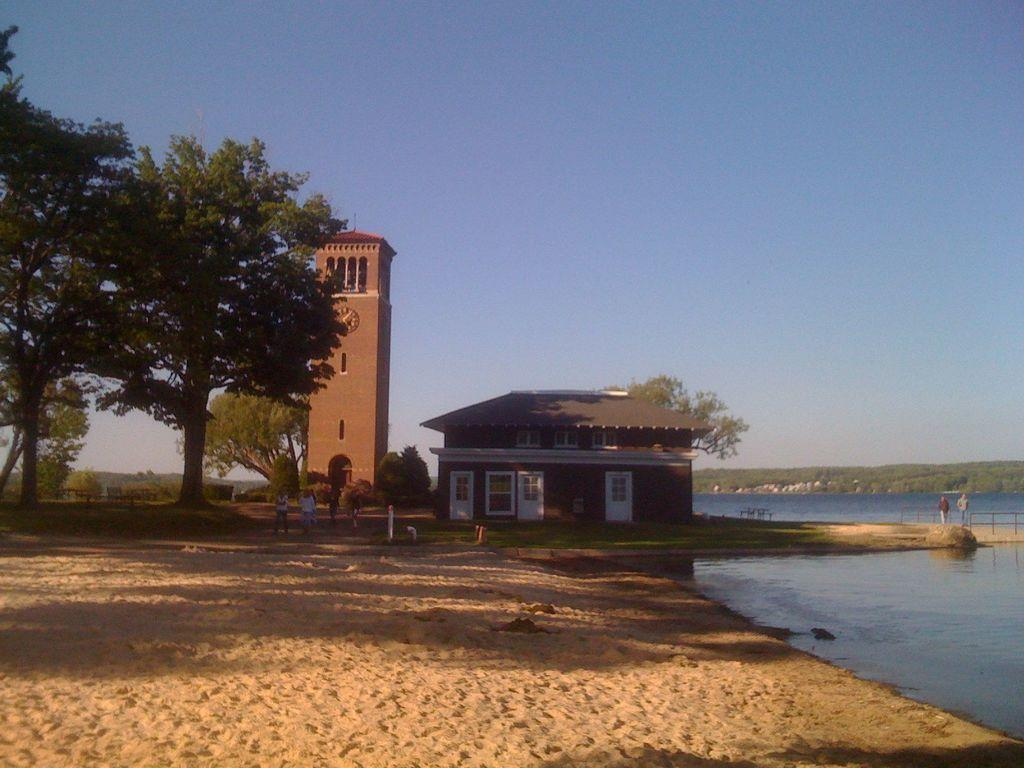What type of structure can be seen in the image? There is a house and a tower in the image. What time-related object is present in the image? There is a clock in the image. What type of vegetation is visible in the image? There are trees and grass in the image. What is the background of the image? There is sky visible in the image. Are there any people in the image? Yes, there are people in the image. What type of architectural feature can be seen in the image? There are railings in the image. What natural element is visible in the image? There is water visible in the image. What unspecified objects can be seen in the image? There are unspecified objects in the image. How many bells are hanging from the shelf in the image? There is no shelf present in the image, and therefore no bells hanging from it. 